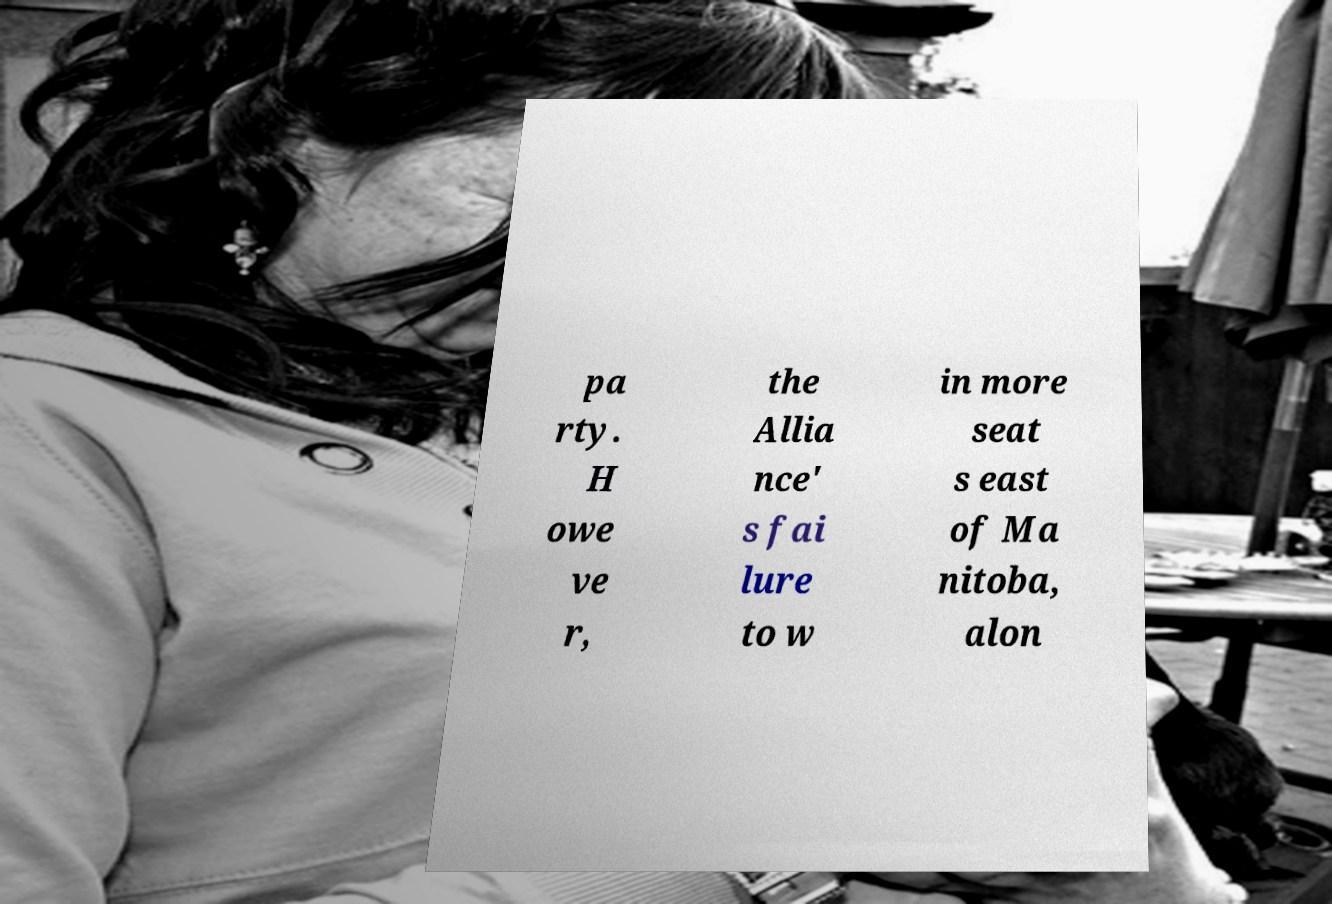Can you accurately transcribe the text from the provided image for me? pa rty. H owe ve r, the Allia nce' s fai lure to w in more seat s east of Ma nitoba, alon 